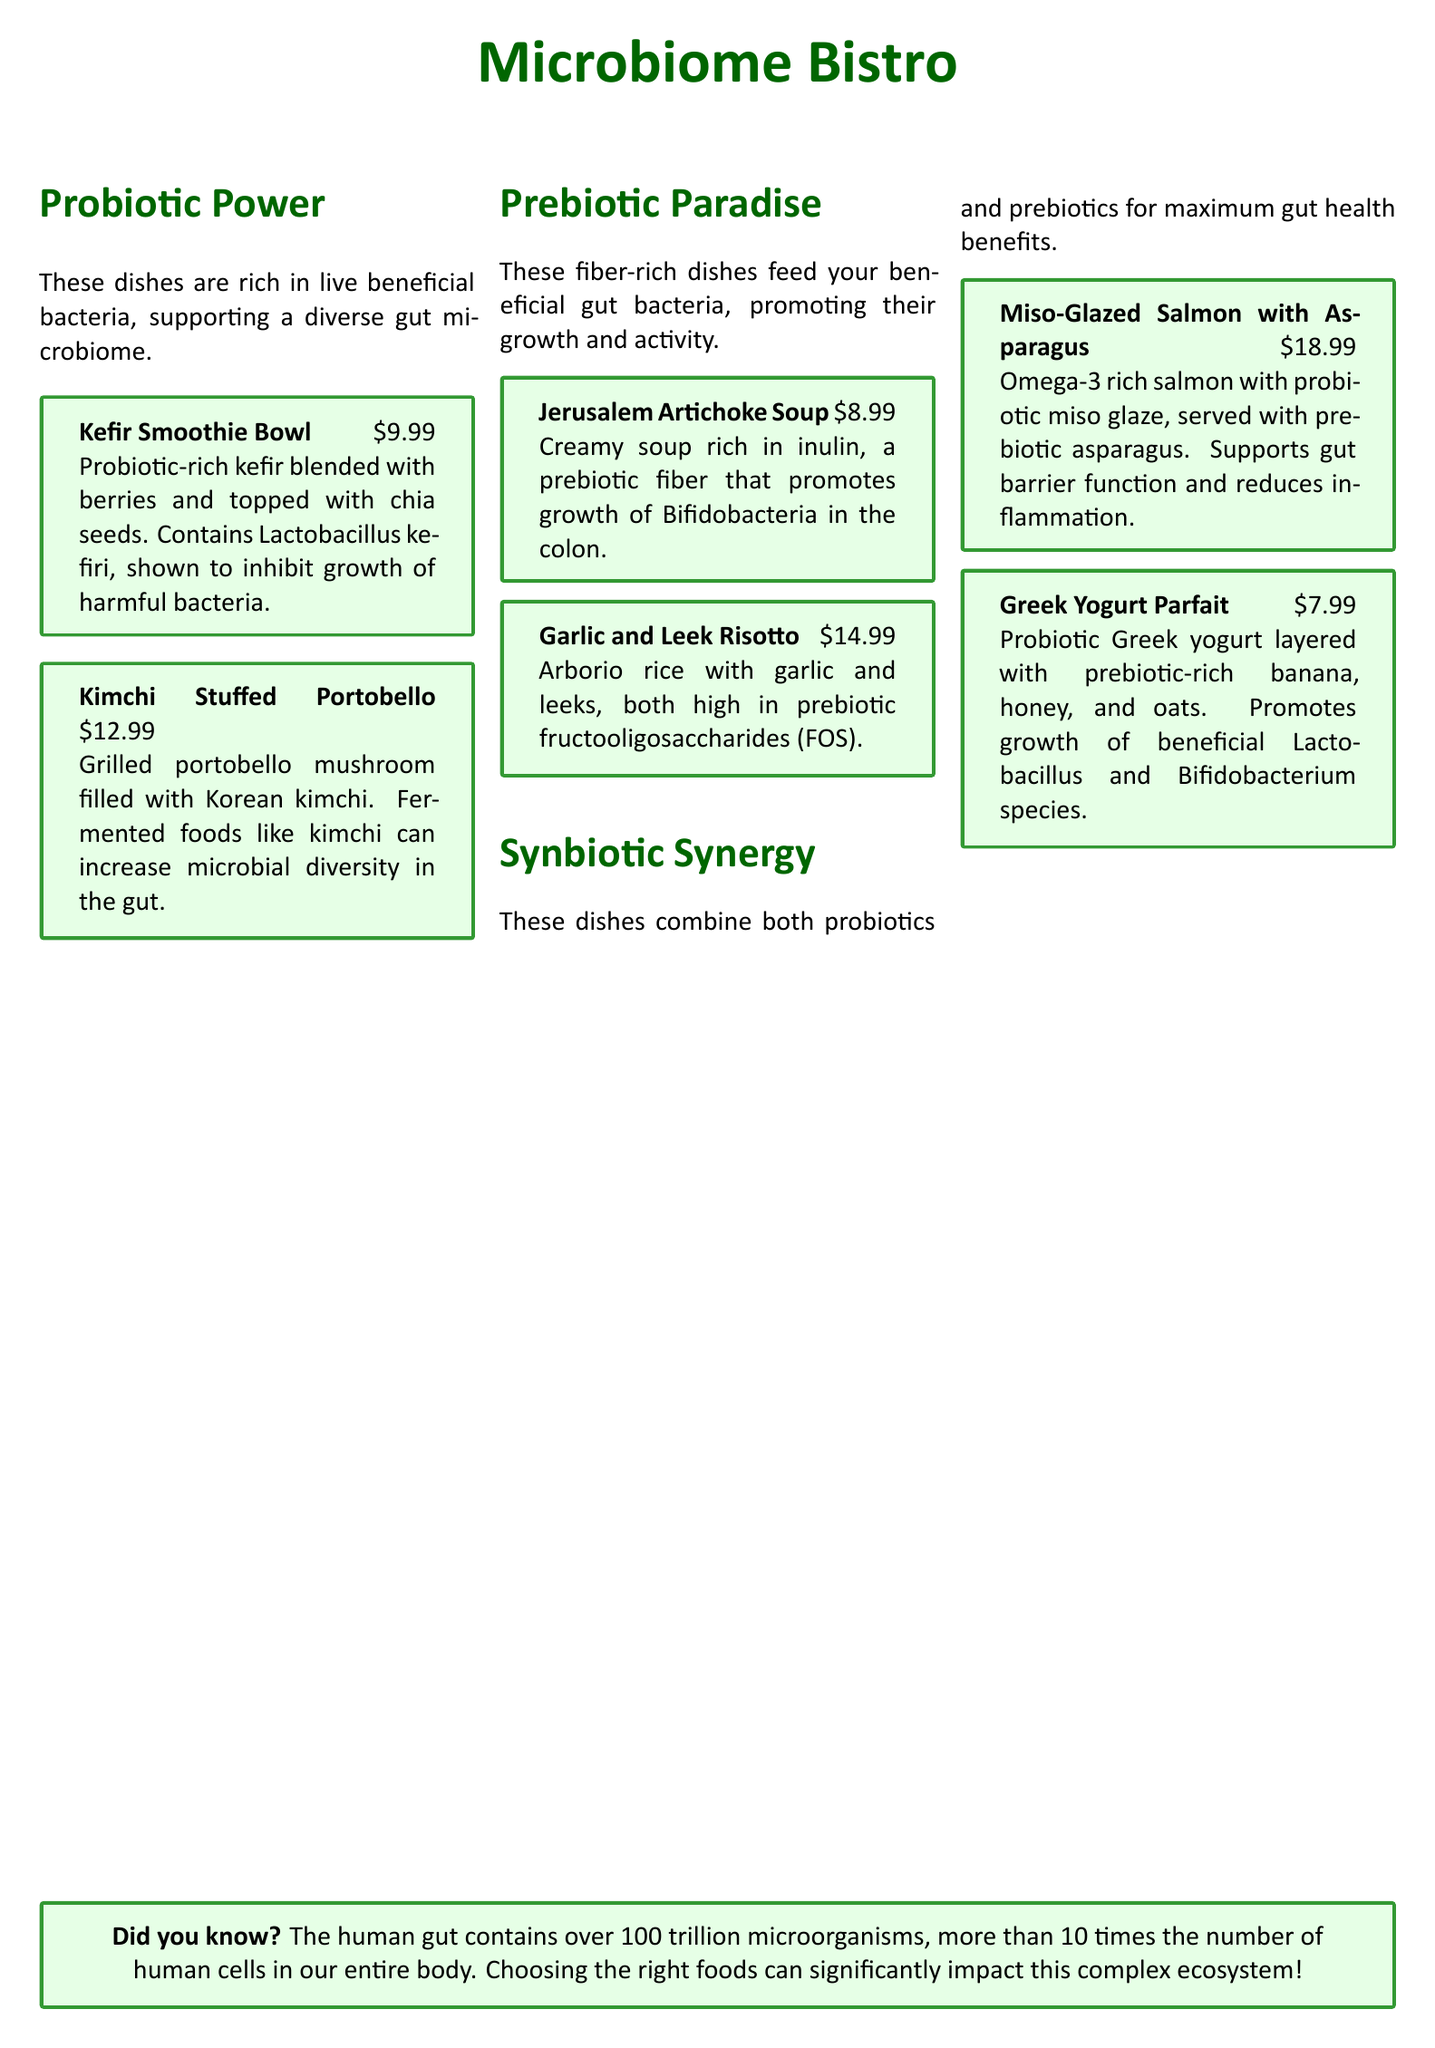What is the price of the Kefir Smoothie Bowl? The price is stated directly next to the dish name in the menu.
Answer: $9.99 What are the two types of dishes listed in the menu? The sections in the menu categorize the dishes based on their health benefits for the gut microbiome.
Answer: Probiotic Power and Prebiotic Paradise Which dish is rich in inulin? The dish description contains information about the specific fiber it contains, highlighting its prebiotic properties.
Answer: Jerusalem Artichoke Soup What benefits do fermented foods like kimchi provide? The menu specifically states the impact of kimchi on gut microbiome diversity.
Answer: Increase microbial diversity How much does the Miso-Glazed Salmon with Asparagus cost? The cost of the dish is mentioned in the menu next to the dish title.
Answer: $18.99 What is one benefit of the Greek Yogurt Parfait? The description elaborates on the growth of specific beneficial bacteria due to its ingredients.
Answer: Promotes growth of beneficial Lactobacillus and Bifidobacterium species What are fructooligosaccharides commonly found in? The dish description details the sources of this prebiotic fiber.
Answer: Garlic and Leek Risotto What kind of rice is used in the Garlic and Leek Risotto? The menu specifies the type of rice in this dish.
Answer: Arborio rice What is mentioned about the human gut in the Did you know section? This section provides interesting facts about gut microbiota and complexity.
Answer: Contains over 100 trillion microorganisms 